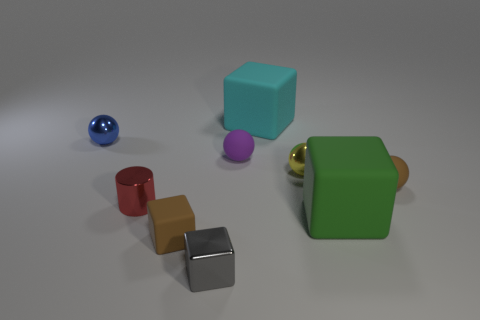Are there more shiny cylinders behind the big green thing than gray metal cubes?
Offer a very short reply. No. What number of other objects are there of the same color as the small metallic cube?
Give a very brief answer. 0. Is the size of the red object that is to the left of the cyan thing the same as the brown cube?
Provide a succinct answer. Yes. Are there any blue metal cylinders of the same size as the gray cube?
Provide a short and direct response. No. The big block that is behind the blue object is what color?
Offer a terse response. Cyan. What shape is the tiny object that is in front of the green rubber block and to the left of the tiny gray metallic block?
Offer a terse response. Cube. How many tiny brown matte things have the same shape as the big cyan thing?
Your answer should be very brief. 1. What number of small brown matte cubes are there?
Ensure brevity in your answer.  1. There is a object that is both to the right of the small metallic block and behind the purple sphere; what size is it?
Your response must be concise. Large. There is a gray thing that is the same size as the blue thing; what shape is it?
Offer a terse response. Cube. 